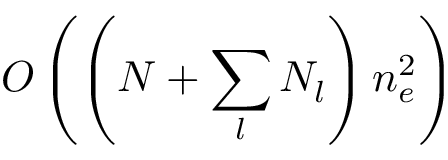Convert formula to latex. <formula><loc_0><loc_0><loc_500><loc_500>O \left ( \left ( N + \sum _ { l } N _ { l } \right ) n _ { e } ^ { 2 } \right )</formula> 